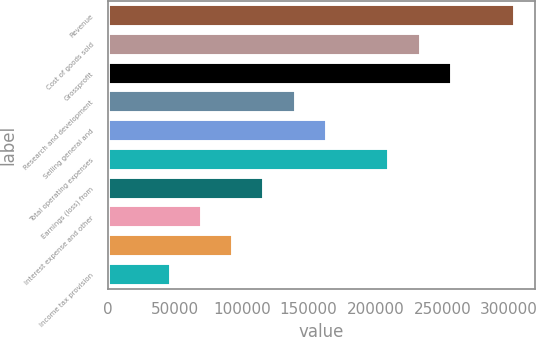Convert chart to OTSL. <chart><loc_0><loc_0><loc_500><loc_500><bar_chart><fcel>Revenue<fcel>Cost of goods sold<fcel>Grossprofit<fcel>Research and development<fcel>Selling general and<fcel>Total operating expenses<fcel>Earnings (loss) from<fcel>Interest expense and other<fcel>Unnamed: 8<fcel>Income tax provision<nl><fcel>304011<fcel>233855<fcel>257240<fcel>140313<fcel>163699<fcel>210470<fcel>116928<fcel>70156.7<fcel>93542.1<fcel>46771.2<nl></chart> 